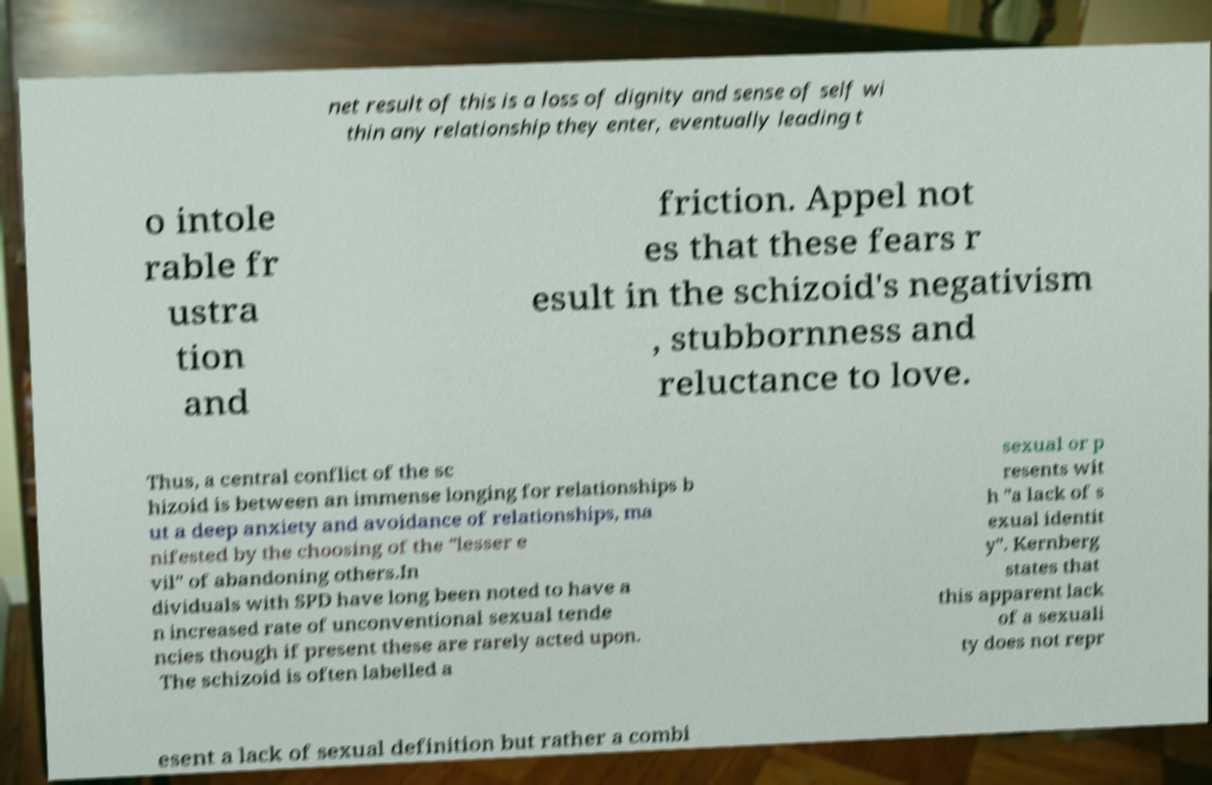Can you read and provide the text displayed in the image?This photo seems to have some interesting text. Can you extract and type it out for me? net result of this is a loss of dignity and sense of self wi thin any relationship they enter, eventually leading t o intole rable fr ustra tion and friction. Appel not es that these fears r esult in the schizoid's negativism , stubbornness and reluctance to love. Thus, a central conflict of the sc hizoid is between an immense longing for relationships b ut a deep anxiety and avoidance of relationships, ma nifested by the choosing of the "lesser e vil" of abandoning others.In dividuals with SPD have long been noted to have a n increased rate of unconventional sexual tende ncies though if present these are rarely acted upon. The schizoid is often labelled a sexual or p resents wit h "a lack of s exual identit y". Kernberg states that this apparent lack of a sexuali ty does not repr esent a lack of sexual definition but rather a combi 